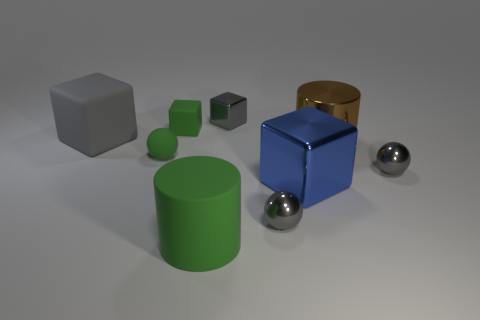Are there any small red things that have the same material as the brown cylinder?
Provide a succinct answer. No. Is the large gray thing made of the same material as the large blue object?
Keep it short and to the point. No. How many matte cubes are behind the gray cube to the left of the big green matte object?
Your response must be concise. 1. What number of cyan things are metal spheres or big things?
Your answer should be very brief. 0. There is a large object that is left of the small block that is on the left side of the tiny block to the right of the big green rubber cylinder; what shape is it?
Make the answer very short. Cube. There is a matte object that is the same size as the green matte sphere; what color is it?
Provide a succinct answer. Green. How many big red metallic things are the same shape as the gray matte object?
Ensure brevity in your answer.  0. There is a blue shiny object; is its size the same as the green rubber cube behind the big gray matte block?
Give a very brief answer. No. What is the shape of the gray thing that is to the left of the metal thing that is behind the large gray rubber block?
Your response must be concise. Cube. Are there fewer tiny rubber blocks that are in front of the tiny green cube than small blue shiny things?
Offer a terse response. No. 